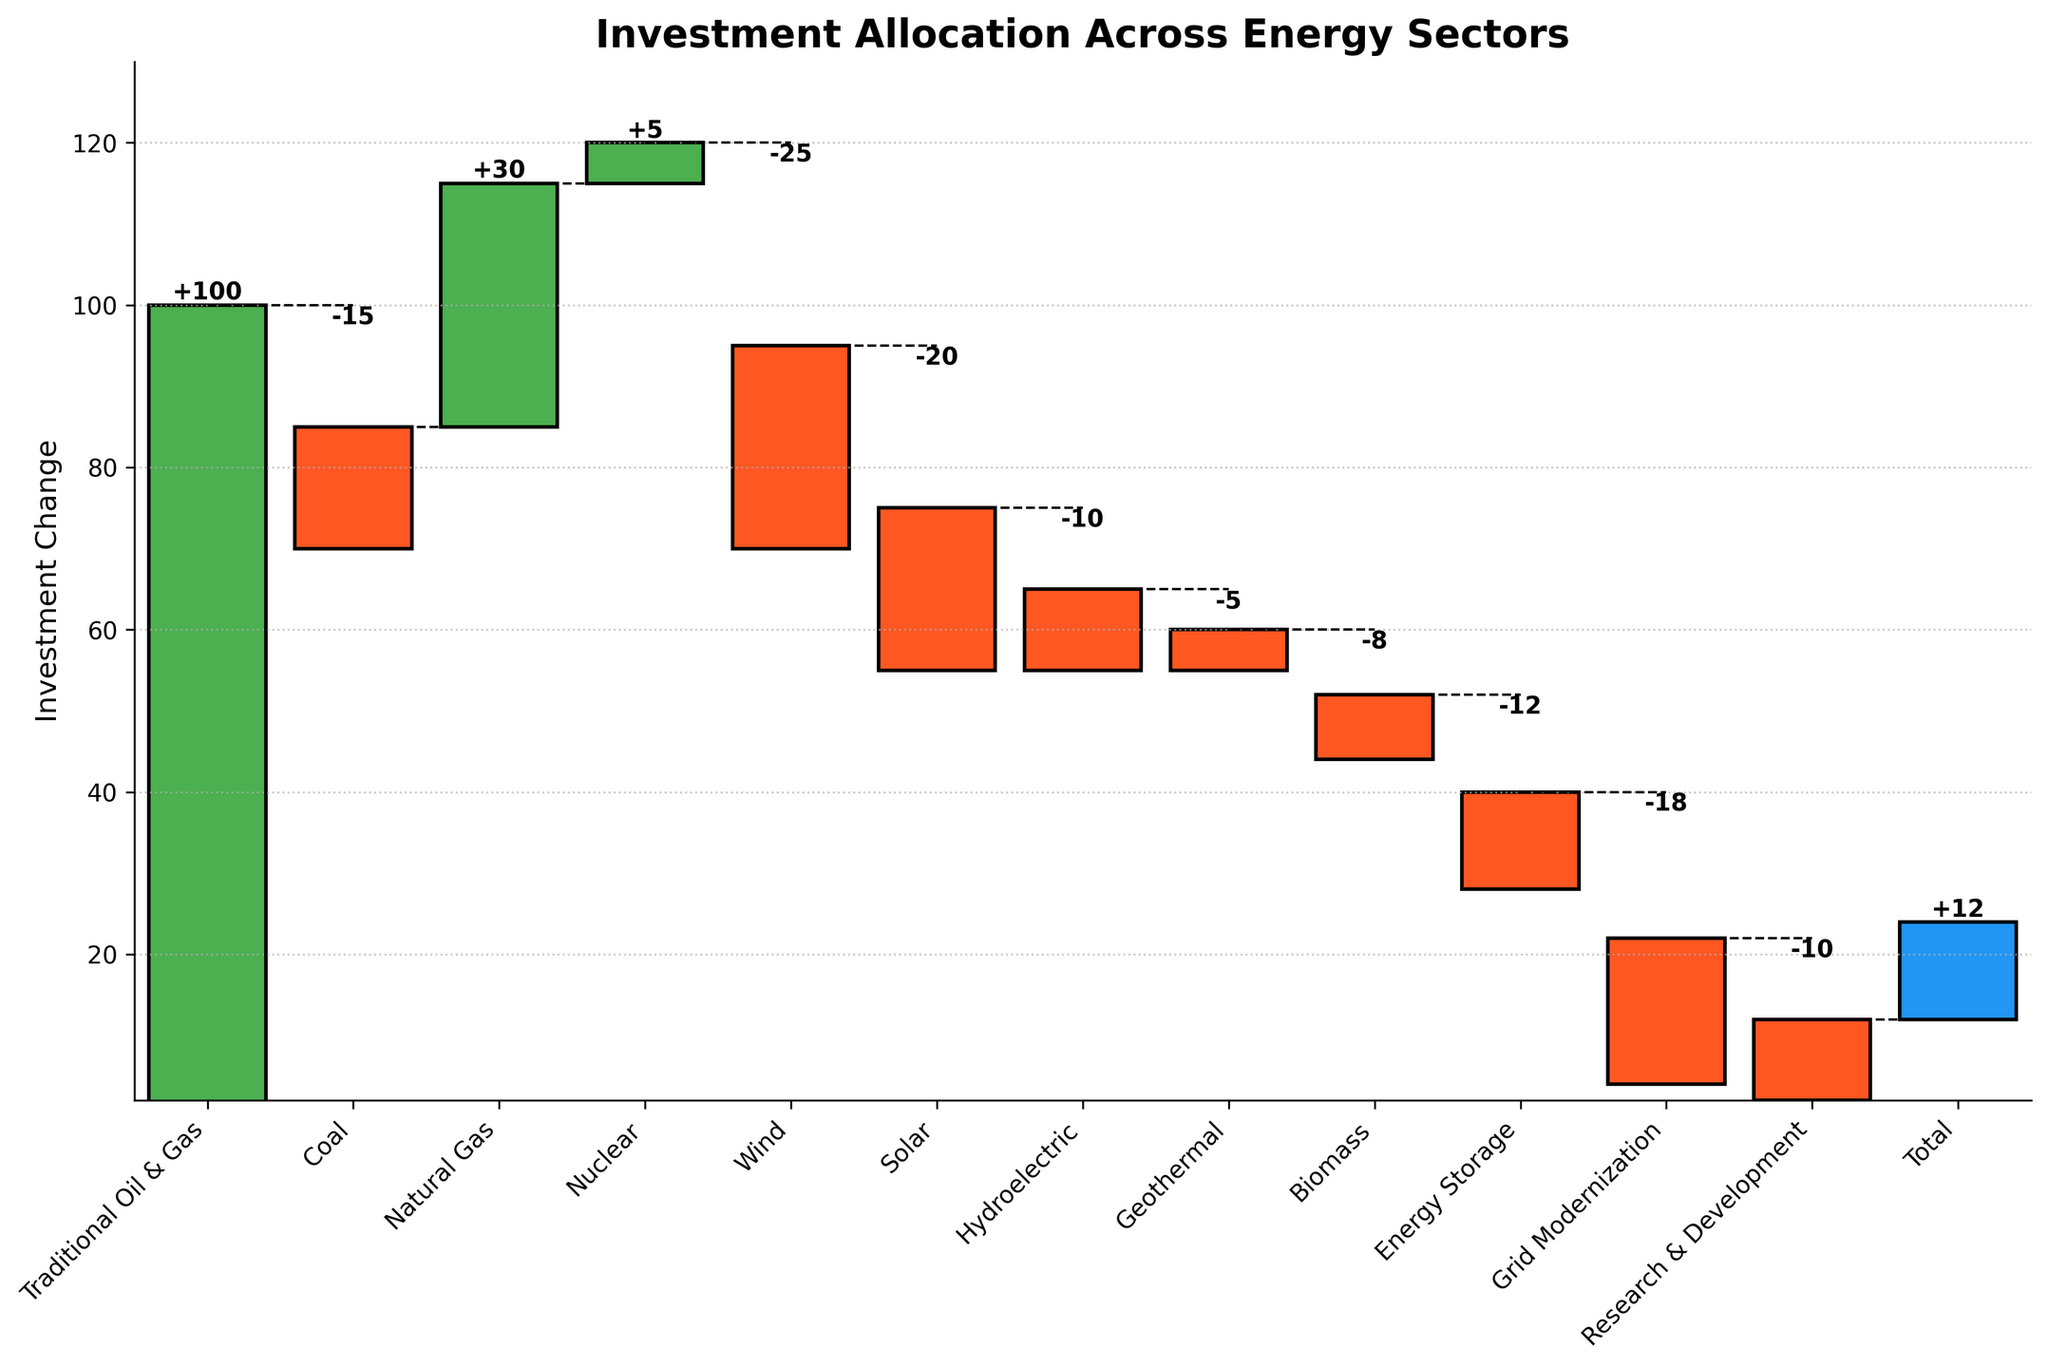What is the title of the chart? The title of the chart is displayed at the top of the figure. It is clearly indicated.
Answer: Investment Allocation Across Energy Sectors How many categories are shown in the chart? The categories can be identified by counting the labels on the x-axis. Each label represents a category.
Answer: 12 Which category shows the highest positive investment change? By inspecting the height and value labels of the green bars, the category with the highest positive value is identified.
Answer: Traditional Oil & Gas Which category has the largest negative investment change? By looking at the height and value labels of the red bars, the category with the most significant negative value is determined.
Answer: Wind What is the total investment change? This is indicated by the label on the last bar of the chart, which represents the sum of all changes.
Answer: 12 What is the cumulative investment change after the Coal and Natural Gas categories? To find this, add the values of "Coal" and "Natural Gas" to the initial cumulative value ("Traditional Oil & Gas").
Answer: 115 Compare the investment change in Solar and Energy Storage. Which one has a greater negative impact? By examining the magnitude of the negative values on each corresponding bar, determine which is larger.
Answer: Solar What is the cumulative investment change from Traditional Oil & Gas to Nuclear? Add the values of "Traditional Oil & Gas," "Coal," "Natural Gas," and "Nuclear" to get the cumulative sum.
Answer: 120 How does the investment change in Grid Modernization compare to that in Energy Storage? By comparing the negative values of both categories directly from the chart, see which is larger.
Answer: Grid Modernization What is the overall trend shown by the investment changes across renewable energy sectors (Wind, Solar, Hydroelectric, Geothermal, Biomass)? Summarize the cumulative impact across these categories by combining their values.
Answer: -68 